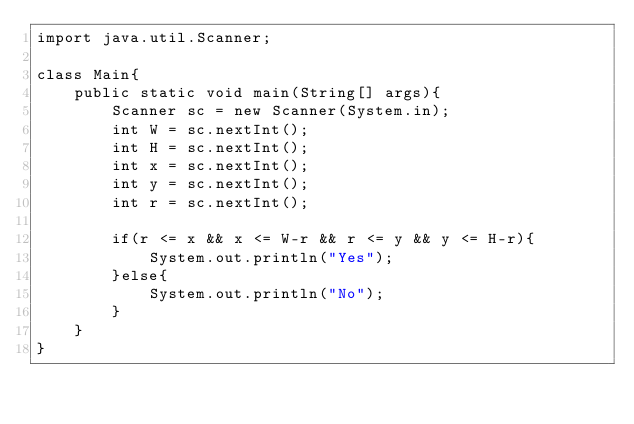<code> <loc_0><loc_0><loc_500><loc_500><_Java_>import java.util.Scanner;

class Main{
    public static void main(String[] args){
        Scanner sc = new Scanner(System.in);
        int W = sc.nextInt();
        int H = sc.nextInt();
        int x = sc.nextInt();
        int y = sc.nextInt();
        int r = sc.nextInt();
        
        if(r <= x && x <= W-r && r <= y && y <= H-r){
            System.out.println("Yes");
        }else{
            System.out.println("No");
        }
    }
}
</code> 